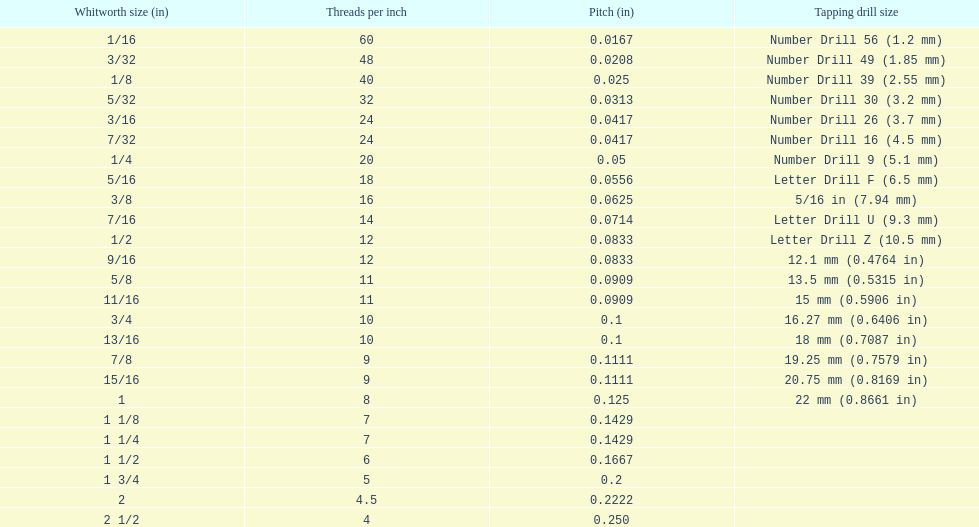Which core diameter (in) succeeds 0.1162. 